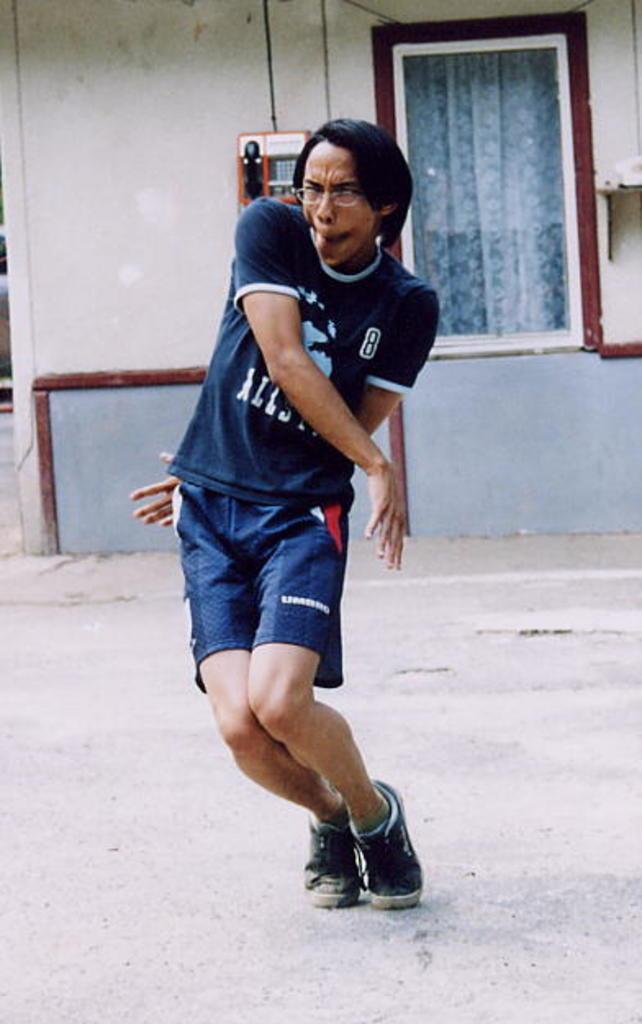Could you give a brief overview of what you see in this image? This picture is clicked outside. In the center we can see a person wearing blue color t-shirt and seems to be dancing on the ground. In the background we can see the telephone attached to the wall of a house and we can see the window and the curtain and some other objects. 